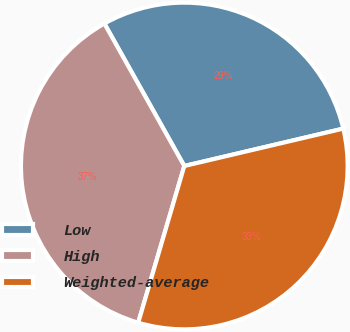Convert chart. <chart><loc_0><loc_0><loc_500><loc_500><pie_chart><fcel>Low<fcel>High<fcel>Weighted-average<nl><fcel>29.46%<fcel>37.31%<fcel>33.23%<nl></chart> 